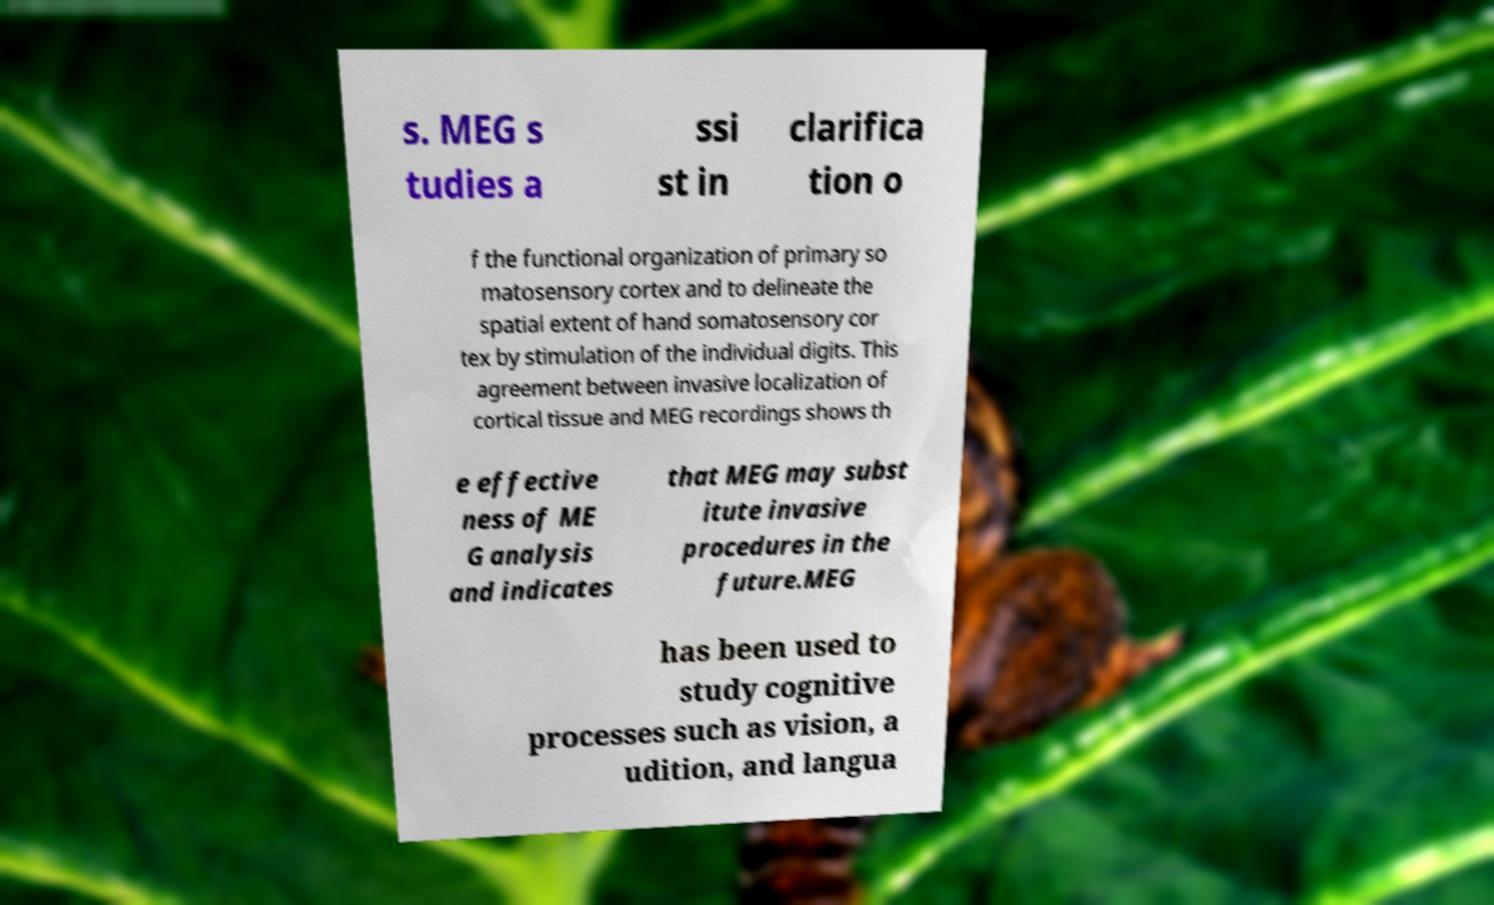Could you extract and type out the text from this image? s. MEG s tudies a ssi st in clarifica tion o f the functional organization of primary so matosensory cortex and to delineate the spatial extent of hand somatosensory cor tex by stimulation of the individual digits. This agreement between invasive localization of cortical tissue and MEG recordings shows th e effective ness of ME G analysis and indicates that MEG may subst itute invasive procedures in the future.MEG has been used to study cognitive processes such as vision, a udition, and langua 